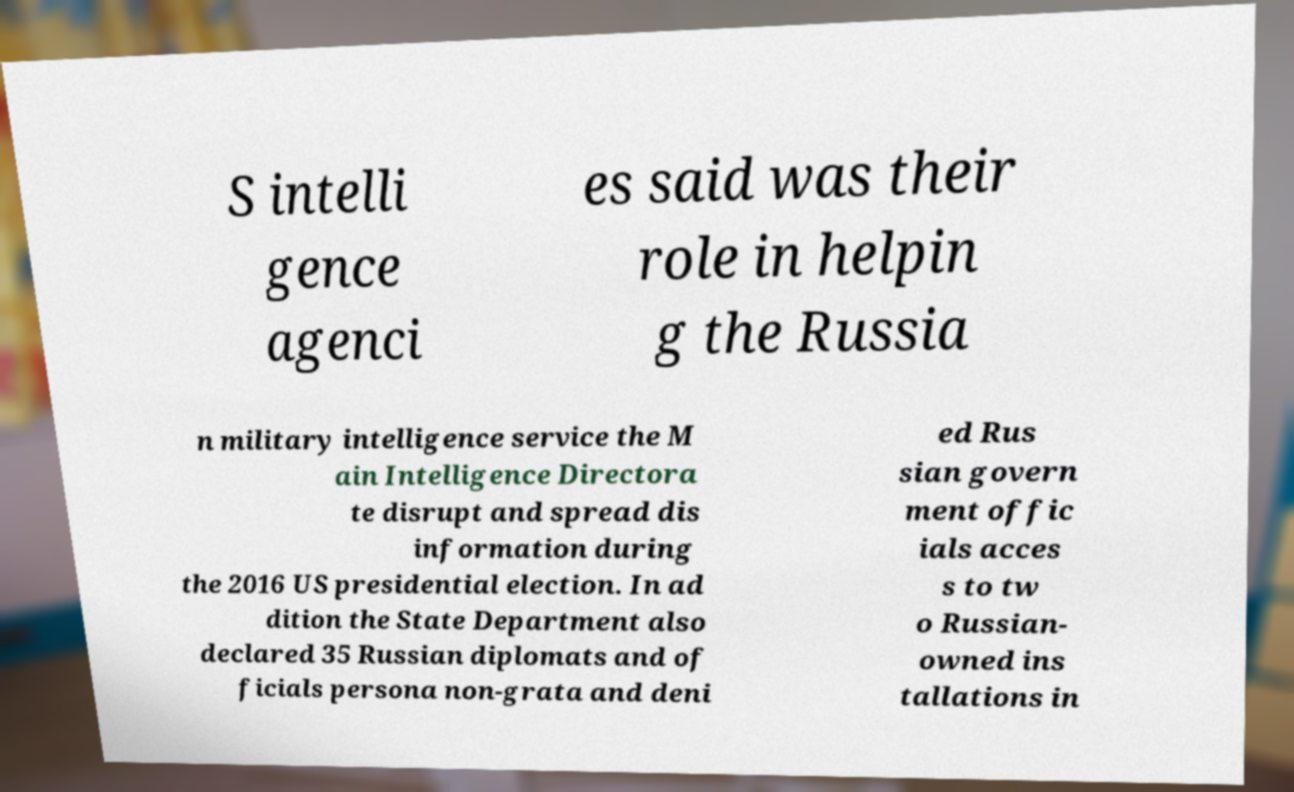Can you read and provide the text displayed in the image?This photo seems to have some interesting text. Can you extract and type it out for me? S intelli gence agenci es said was their role in helpin g the Russia n military intelligence service the M ain Intelligence Directora te disrupt and spread dis information during the 2016 US presidential election. In ad dition the State Department also declared 35 Russian diplomats and of ficials persona non-grata and deni ed Rus sian govern ment offic ials acces s to tw o Russian- owned ins tallations in 